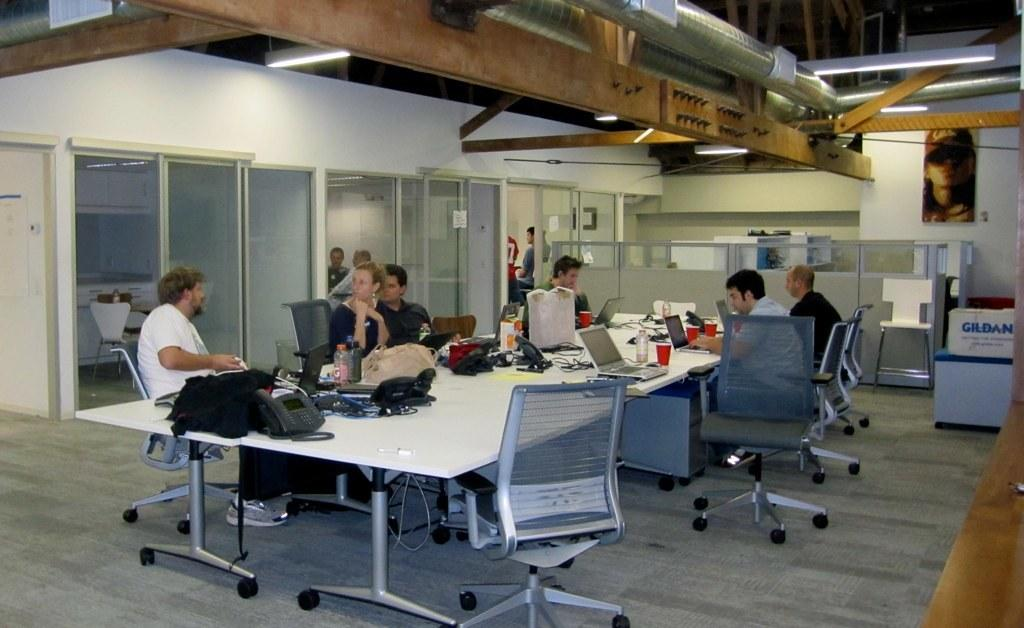How many people are in the group in the image? There is a group of people in the image, but the exact number is not specified. What are the people in the group doing? The people in the group are sitting. What is on the table in front of the group? There is a laptop, a water bottle, and glasses on the table. What else can be seen on or near the table? There are bags on or near the table. What else is visible in the image? There are cables visible in the image, as well as other unspecified items. How does the group of people express their hatred for each other in the image? There is no indication of hate or animosity between the people in the image; they are simply sitting together. What type of motion is depicted in the image? The image does not depict any motion; the people are sitting and the objects are stationary. 